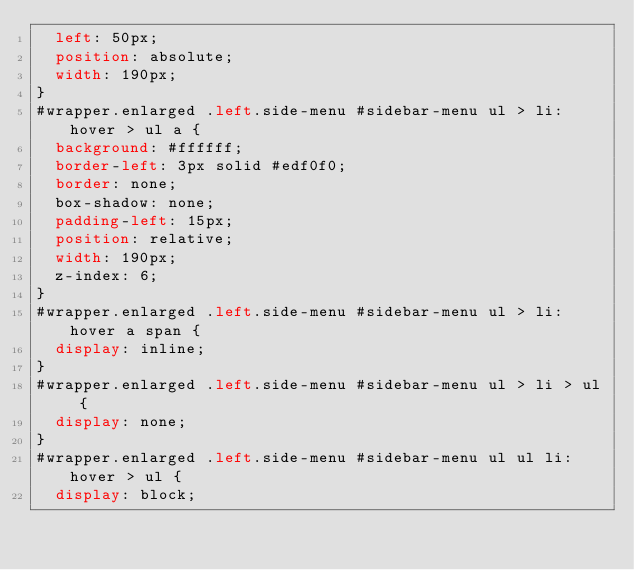Convert code to text. <code><loc_0><loc_0><loc_500><loc_500><_CSS_>  left: 50px;
  position: absolute;
  width: 190px;
}
#wrapper.enlarged .left.side-menu #sidebar-menu ul > li:hover > ul a {
  background: #ffffff;
  border-left: 3px solid #edf0f0;
  border: none;
  box-shadow: none;
  padding-left: 15px;
  position: relative;
  width: 190px;
  z-index: 6;
}
#wrapper.enlarged .left.side-menu #sidebar-menu ul > li:hover a span {
  display: inline;
}
#wrapper.enlarged .left.side-menu #sidebar-menu ul > li > ul {
  display: none;
}
#wrapper.enlarged .left.side-menu #sidebar-menu ul ul li:hover > ul {
  display: block;</code> 